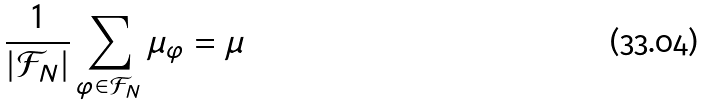Convert formula to latex. <formula><loc_0><loc_0><loc_500><loc_500>\frac { 1 } { | \mathcal { F } _ { N } | } \sum _ { \varphi \in \mathcal { F } _ { N } } \mu _ { \varphi } = \mu</formula> 